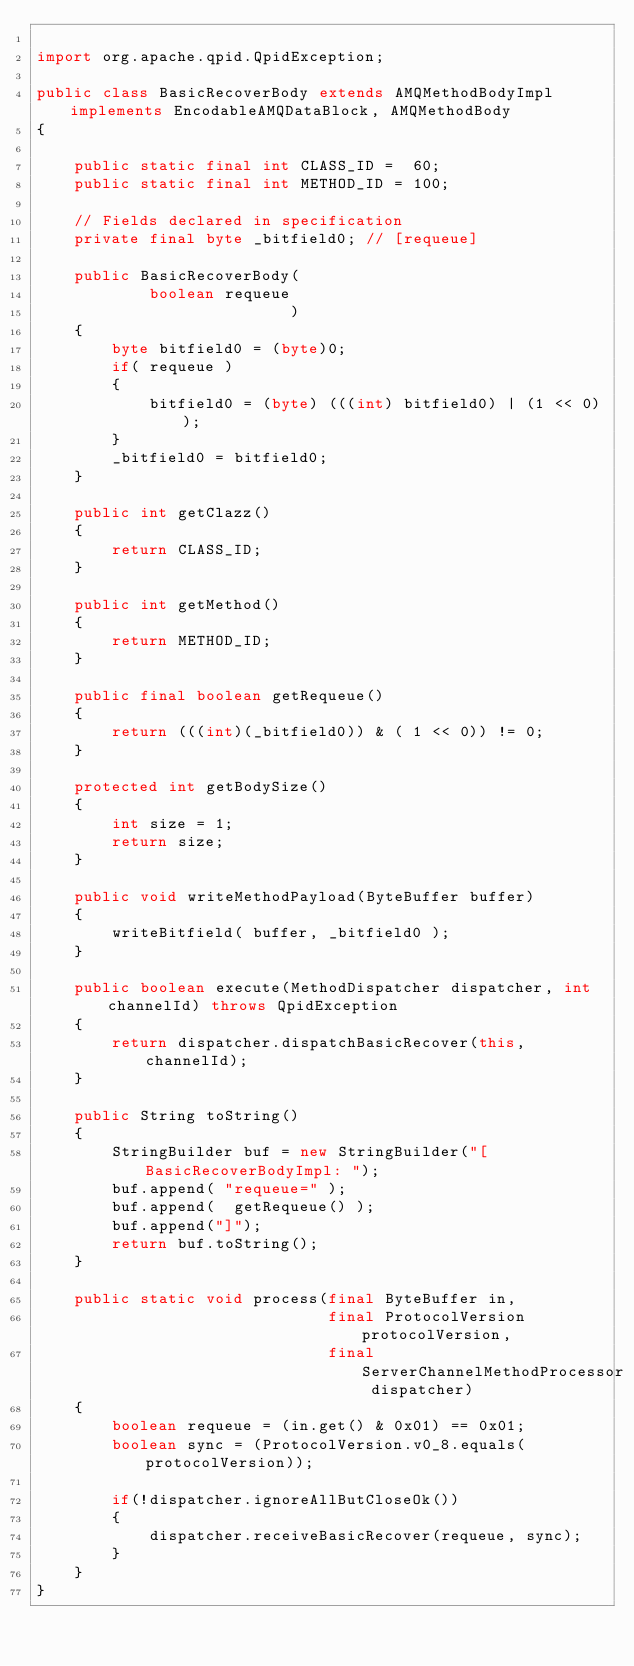Convert code to text. <code><loc_0><loc_0><loc_500><loc_500><_Java_>
import org.apache.qpid.QpidException;

public class BasicRecoverBody extends AMQMethodBodyImpl implements EncodableAMQDataBlock, AMQMethodBody
{

    public static final int CLASS_ID =  60;
    public static final int METHOD_ID = 100;

    // Fields declared in specification
    private final byte _bitfield0; // [requeue]

    public BasicRecoverBody(
            boolean requeue
                           )
    {
        byte bitfield0 = (byte)0;
        if( requeue )
        {
            bitfield0 = (byte) (((int) bitfield0) | (1 << 0));
        }
        _bitfield0 = bitfield0;
    }

    public int getClazz()
    {
        return CLASS_ID;
    }

    public int getMethod()
    {
        return METHOD_ID;
    }

    public final boolean getRequeue()
    {
        return (((int)(_bitfield0)) & ( 1 << 0)) != 0;
    }

    protected int getBodySize()
    {
        int size = 1;
        return size;
    }

    public void writeMethodPayload(ByteBuffer buffer)
    {
        writeBitfield( buffer, _bitfield0 );
    }

    public boolean execute(MethodDispatcher dispatcher, int channelId) throws QpidException
	{
        return dispatcher.dispatchBasicRecover(this, channelId);
	}

    public String toString()
    {
        StringBuilder buf = new StringBuilder("[BasicRecoverBodyImpl: ");
        buf.append( "requeue=" );
        buf.append(  getRequeue() );
        buf.append("]");
        return buf.toString();
    }

    public static void process(final ByteBuffer in,
                               final ProtocolVersion protocolVersion,
                               final ServerChannelMethodProcessor dispatcher)
    {
        boolean requeue = (in.get() & 0x01) == 0x01;
        boolean sync = (ProtocolVersion.v0_8.equals(protocolVersion));

        if(!dispatcher.ignoreAllButCloseOk())
        {
            dispatcher.receiveBasicRecover(requeue, sync);
        }
    }
}
</code> 